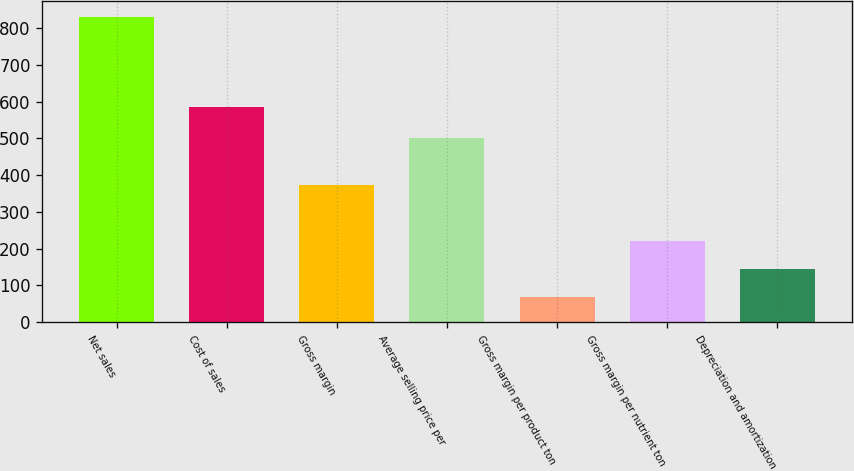Convert chart. <chart><loc_0><loc_0><loc_500><loc_500><bar_chart><fcel>Net sales<fcel>Cost of sales<fcel>Gross margin<fcel>Average selling price per<fcel>Gross margin per product ton<fcel>Gross margin per nutrient ton<fcel>Depreciation and amortization<nl><fcel>831<fcel>584<fcel>373.8<fcel>502<fcel>69<fcel>221.4<fcel>145.2<nl></chart> 